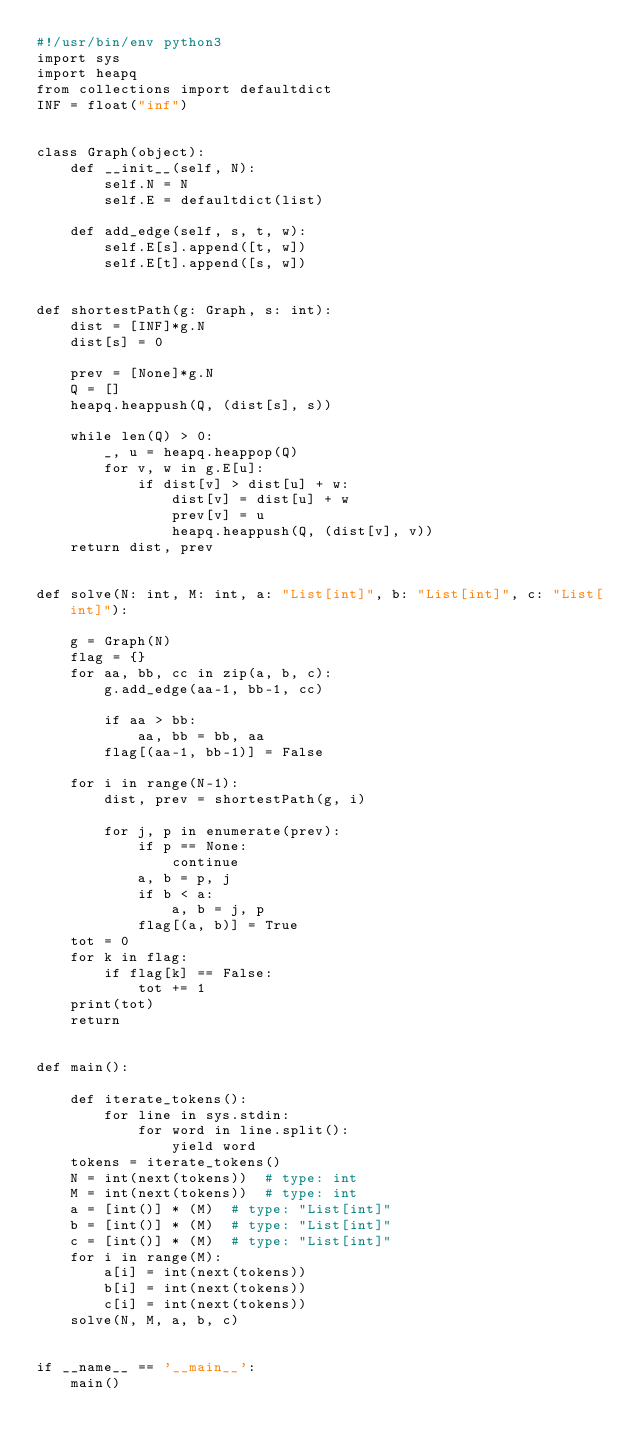<code> <loc_0><loc_0><loc_500><loc_500><_Python_>#!/usr/bin/env python3
import sys
import heapq
from collections import defaultdict
INF = float("inf")


class Graph(object):
    def __init__(self, N):
        self.N = N
        self.E = defaultdict(list)

    def add_edge(self, s, t, w):
        self.E[s].append([t, w])
        self.E[t].append([s, w])


def shortestPath(g: Graph, s: int):
    dist = [INF]*g.N
    dist[s] = 0

    prev = [None]*g.N
    Q = []
    heapq.heappush(Q, (dist[s], s))

    while len(Q) > 0:
        _, u = heapq.heappop(Q)
        for v, w in g.E[u]:
            if dist[v] > dist[u] + w:
                dist[v] = dist[u] + w
                prev[v] = u
                heapq.heappush(Q, (dist[v], v))
    return dist, prev


def solve(N: int, M: int, a: "List[int]", b: "List[int]", c: "List[int]"):

    g = Graph(N)
    flag = {}
    for aa, bb, cc in zip(a, b, c):
        g.add_edge(aa-1, bb-1, cc)

        if aa > bb:
            aa, bb = bb, aa
        flag[(aa-1, bb-1)] = False

    for i in range(N-1):
        dist, prev = shortestPath(g, i)

        for j, p in enumerate(prev):
            if p == None:
                continue
            a, b = p, j
            if b < a:
                a, b = j, p
            flag[(a, b)] = True
    tot = 0
    for k in flag:
        if flag[k] == False:
            tot += 1
    print(tot)
    return


def main():

    def iterate_tokens():
        for line in sys.stdin:
            for word in line.split():
                yield word
    tokens = iterate_tokens()
    N = int(next(tokens))  # type: int
    M = int(next(tokens))  # type: int
    a = [int()] * (M)  # type: "List[int]"
    b = [int()] * (M)  # type: "List[int]"
    c = [int()] * (M)  # type: "List[int]"
    for i in range(M):
        a[i] = int(next(tokens))
        b[i] = int(next(tokens))
        c[i] = int(next(tokens))
    solve(N, M, a, b, c)


if __name__ == '__main__':
    main()
</code> 